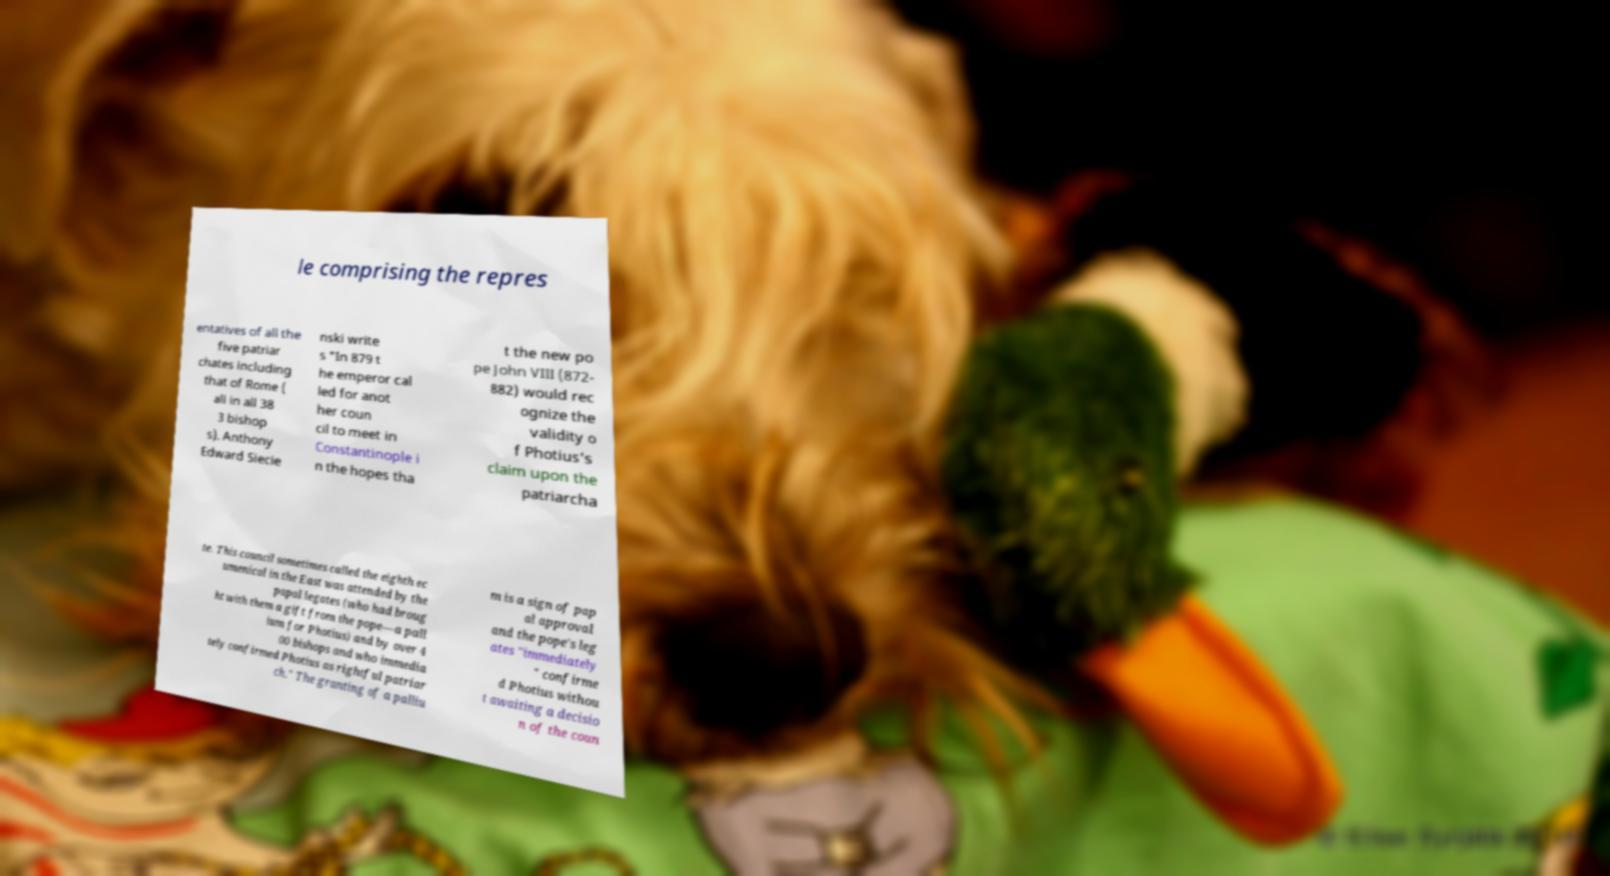Please identify and transcribe the text found in this image. le comprising the repres entatives of all the five patriar chates including that of Rome ( all in all 38 3 bishop s). Anthony Edward Siecie nski write s "In 879 t he emperor cal led for anot her coun cil to meet in Constantinople i n the hopes tha t the new po pe John VIII (872- 882) would rec ognize the validity o f Photius's claim upon the patriarcha te. This council sometimes called the eighth ec umenical in the East was attended by the papal legates (who had broug ht with them a gift from the pope—a pall ium for Photius) and by over 4 00 bishops and who immedia tely confirmed Photius as rightful patriar ch." The granting of a palliu m is a sign of pap al approval and the pope's leg ates "immediately " confirme d Photius withou t awaiting a decisio n of the coun 